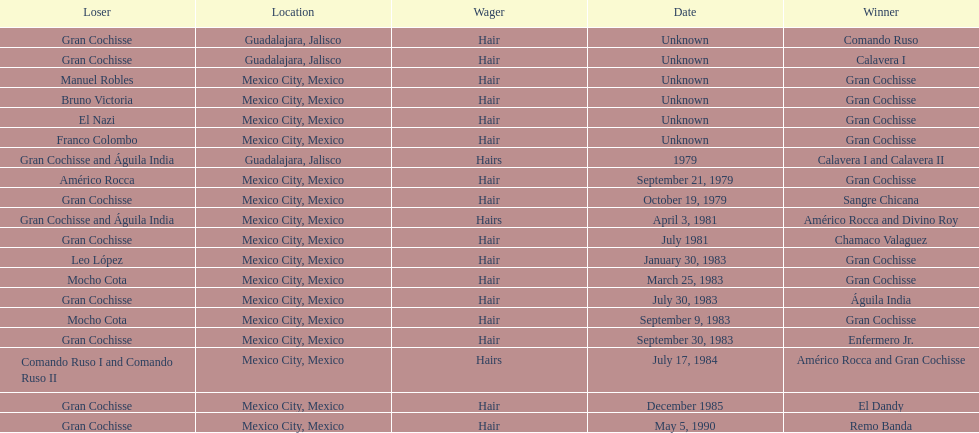When was gran chochisse first match that had a full date on record? September 21, 1979. 